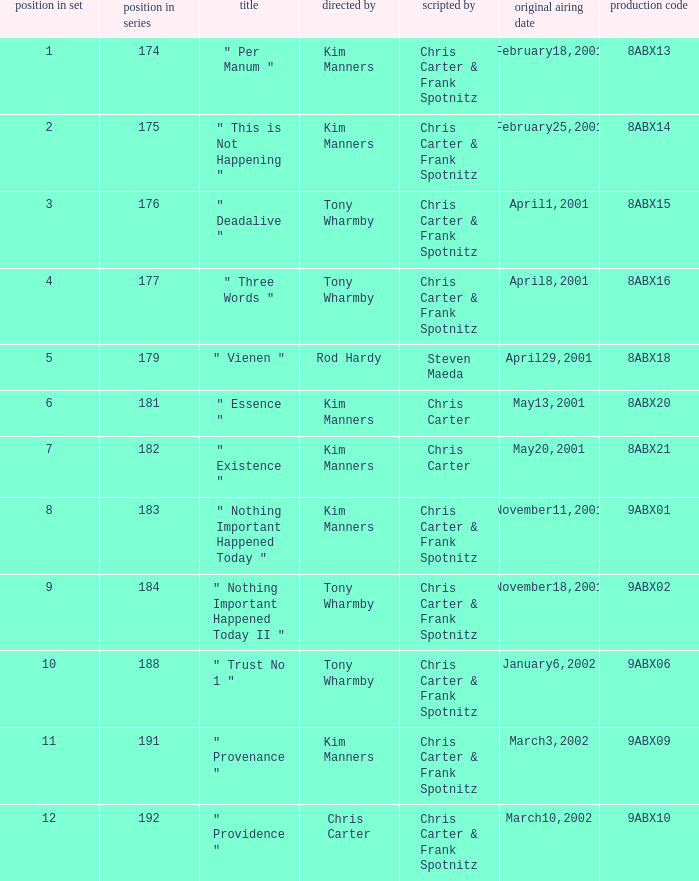The episode with production code 9abx02 was originally aired on what date? November18,2001. 